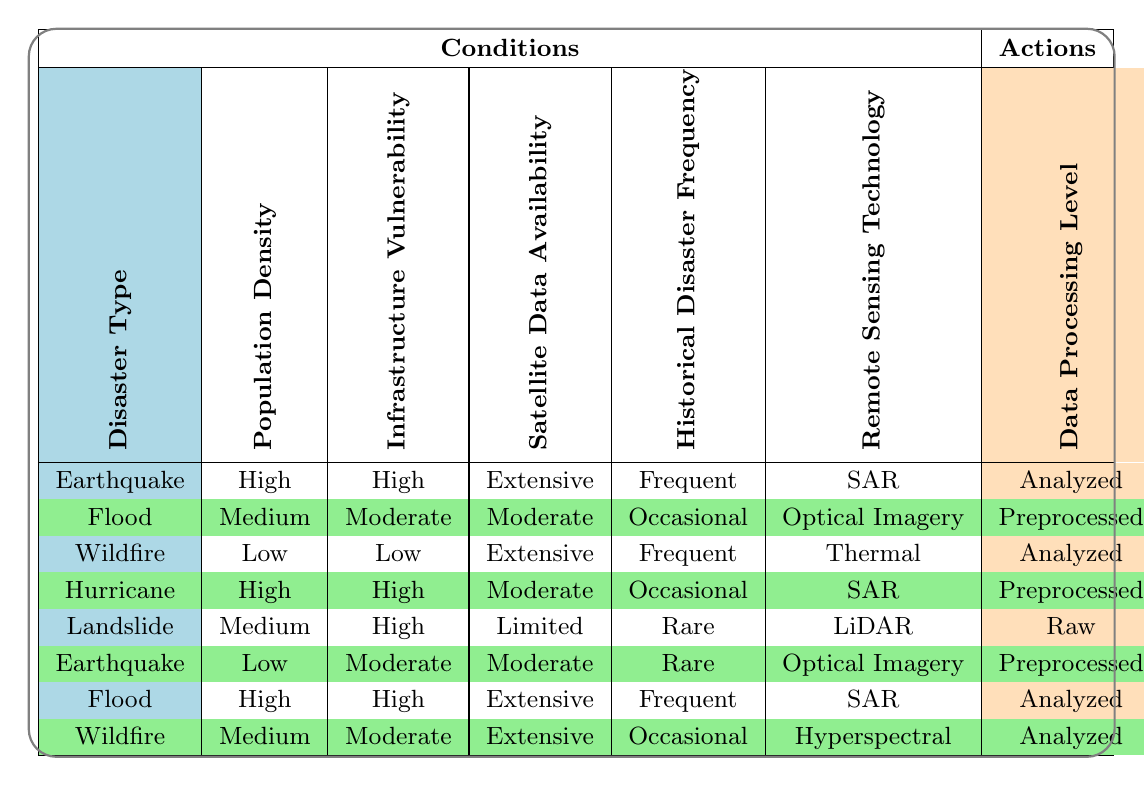What is the recommended remote sensing technology for monitoring hurricanes with high population density? According to the table, for hurricanes with high population density, the remote sensing technology recommended is SAR.
Answer: SAR Which disaster type has a recommended data processing level of "Analyzed"? The disaster types that list "Analyzed" as the recommended data processing level are Earthquake, Wildfire, and Flood, specifically under certain conditions.
Answer: Earthquake, Wildfire, Flood Is it true that the risk assessment model for floods with high infrastructure vulnerability is machine learning? Checking the table, the flood with high infrastructure vulnerability corresponds to SAR as the remote sensing technology and has a risk assessment model classified as Hybrid, not machine learning. Therefore, the statement is false.
Answer: No For which combination of conditions is optical imagery recommended for data processing, and what is the monitoring frequency? For the conditions where optical imagery is recommended, we find Earthquake with Low population density, Moderate infrastructure vulnerability, Moderate satellite data availability, and Rare historical disaster frequency, which has a monitoring frequency of Quarterly.
Answer: Earthquake, Quarterly What is the average monitoring frequency for the disasters listed in the table? To find the average monitoring frequency, we convert the frequencies into their equivalent numerical values: Daily=1, Weekly=2, Monthly=3, Quarterly=4. Summing these frequencies yields 1 (Earthquake) + 2 (Flood) + 1 (Wildfire) + 2 (Hurricane) + 3 (Landslide) + 4 (Earthquake) + 1 (Flood) + 2 (Wildfire) = 16. We have 8 data points, therefore the average frequency is 16/8 = 2.
Answer: 2 Which stakeholder collaboration is recommended for monitoring wildfires with low population density? In the case of wildfires with low population density, the recommended stakeholder collaboration is NGOs, as indicated in the corresponding row of the table.
Answer: NGOs 